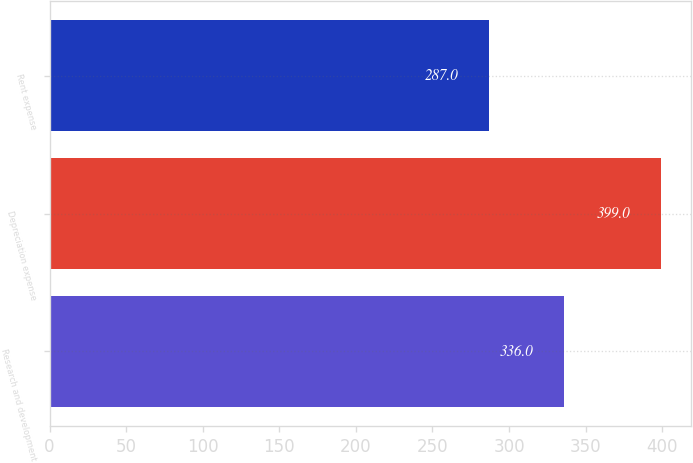Convert chart. <chart><loc_0><loc_0><loc_500><loc_500><bar_chart><fcel>Research and development<fcel>Depreciation expense<fcel>Rent expense<nl><fcel>336<fcel>399<fcel>287<nl></chart> 